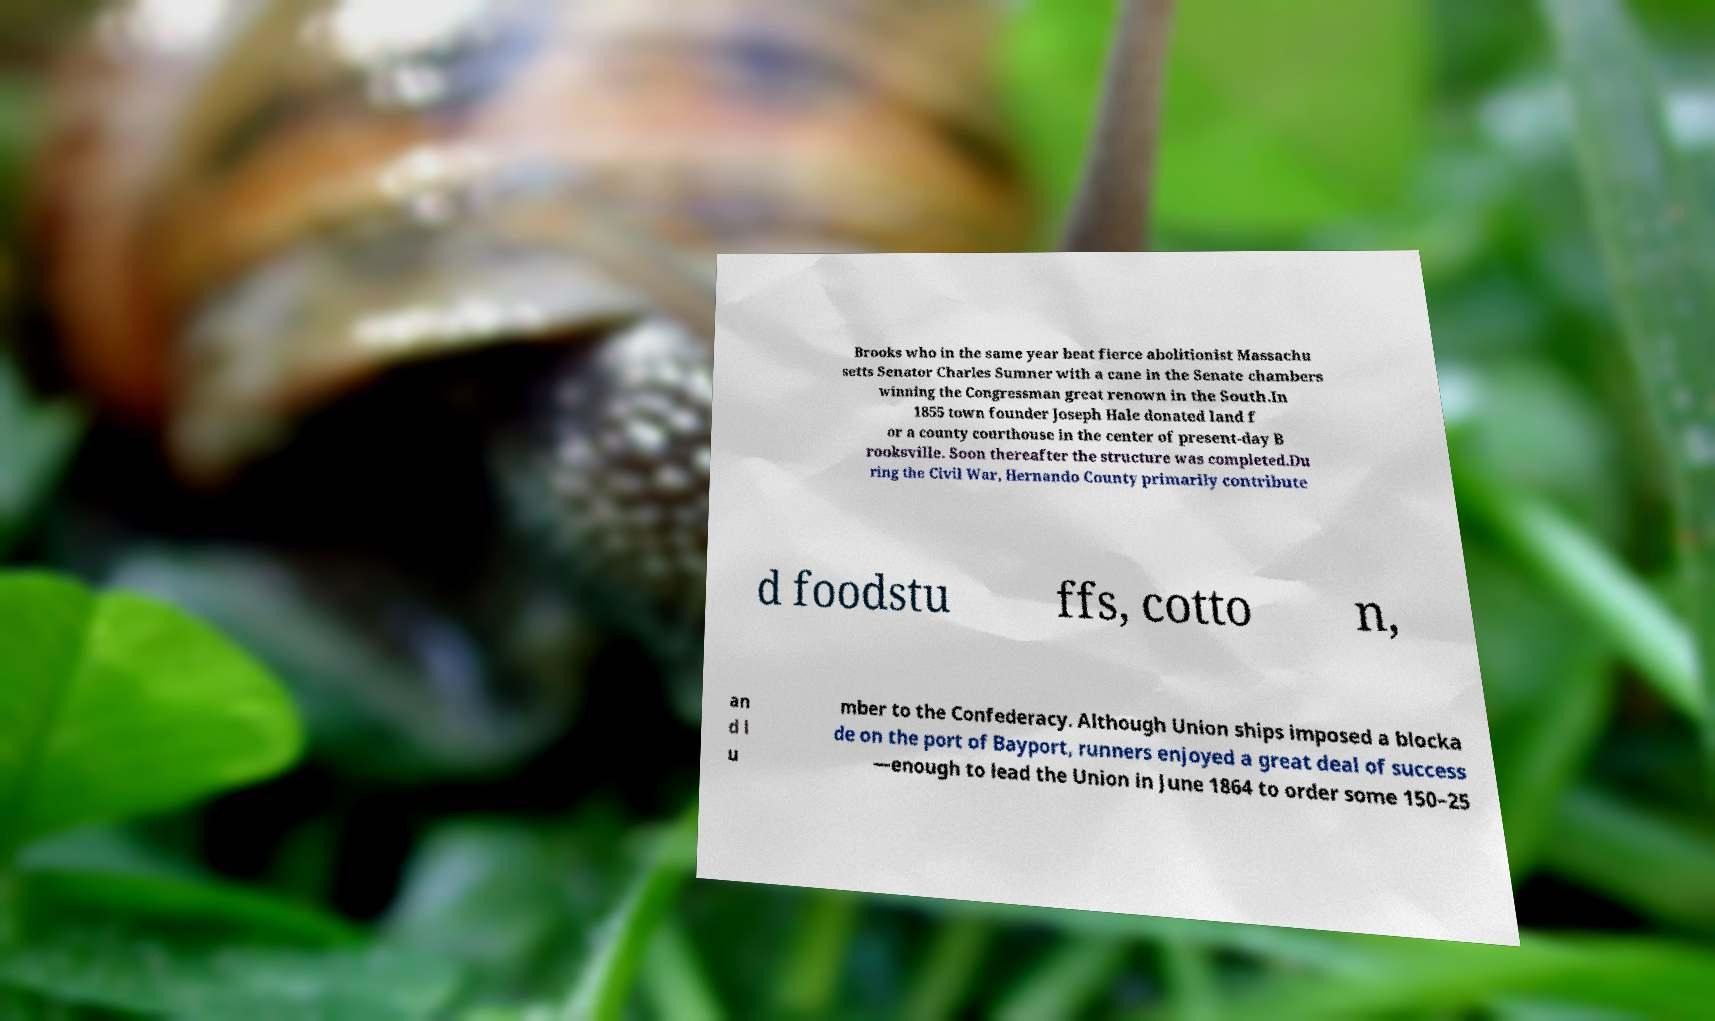Please identify and transcribe the text found in this image. Brooks who in the same year beat fierce abolitionist Massachu setts Senator Charles Sumner with a cane in the Senate chambers winning the Congressman great renown in the South.In 1855 town founder Joseph Hale donated land f or a county courthouse in the center of present-day B rooksville. Soon thereafter the structure was completed.Du ring the Civil War, Hernando County primarily contribute d foodstu ffs, cotto n, an d l u mber to the Confederacy. Although Union ships imposed a blocka de on the port of Bayport, runners enjoyed a great deal of success —enough to lead the Union in June 1864 to order some 150–25 